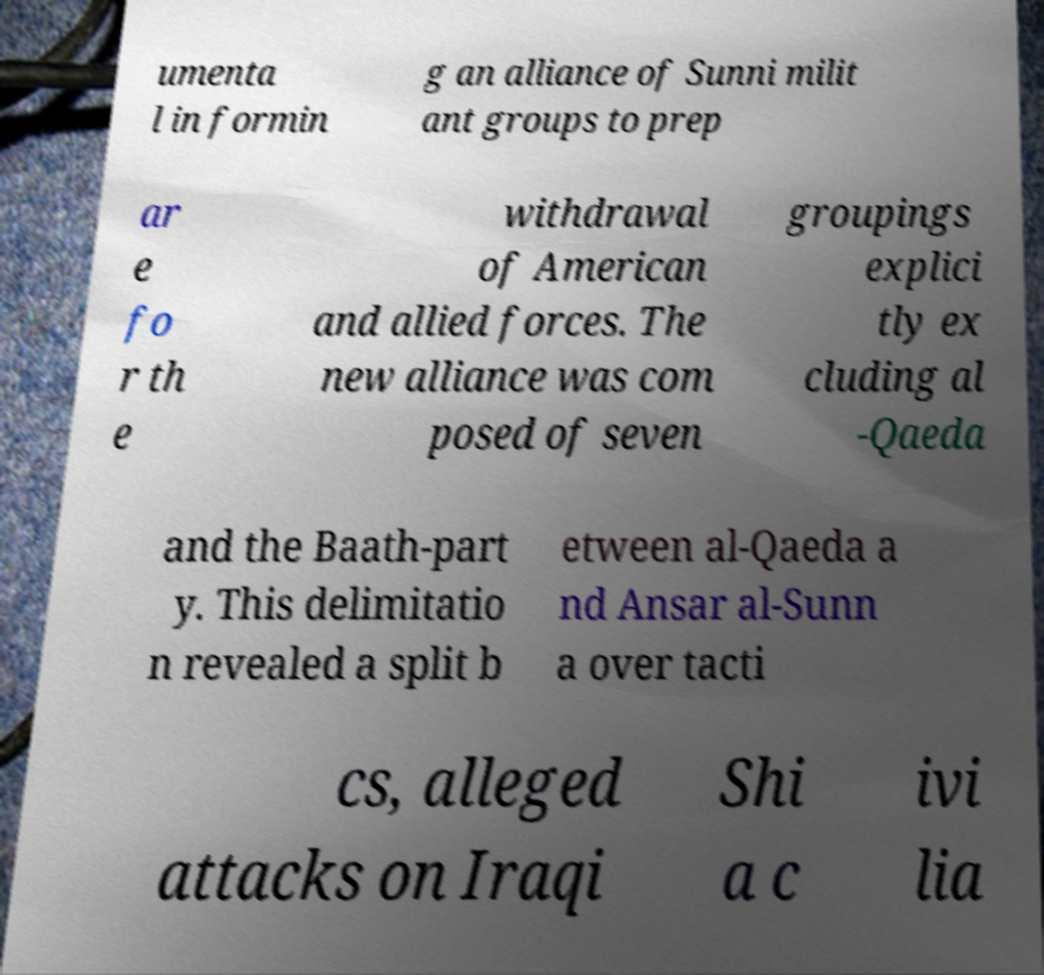What messages or text are displayed in this image? I need them in a readable, typed format. umenta l in formin g an alliance of Sunni milit ant groups to prep ar e fo r th e withdrawal of American and allied forces. The new alliance was com posed of seven groupings explici tly ex cluding al -Qaeda and the Baath-part y. This delimitatio n revealed a split b etween al-Qaeda a nd Ansar al-Sunn a over tacti cs, alleged attacks on Iraqi Shi a c ivi lia 